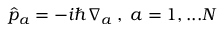Convert formula to latex. <formula><loc_0><loc_0><loc_500><loc_500>\hat { p } _ { a } = - i \hbar { \nabla } _ { a } \, , \, a = 1 , \dots N</formula> 